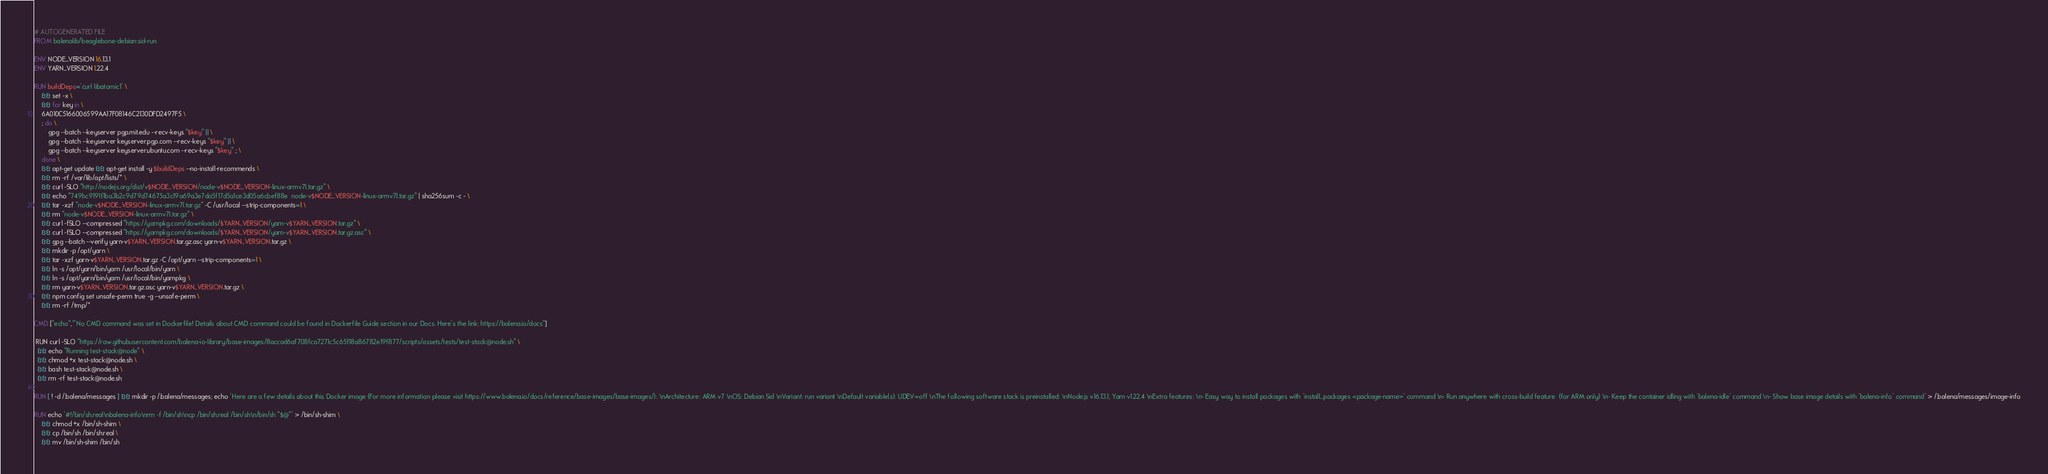Convert code to text. <code><loc_0><loc_0><loc_500><loc_500><_Dockerfile_># AUTOGENERATED FILE
FROM balenalib/beaglebone-debian:sid-run

ENV NODE_VERSION 16.13.1
ENV YARN_VERSION 1.22.4

RUN buildDeps='curl libatomic1' \
	&& set -x \
	&& for key in \
	6A010C5166006599AA17F08146C2130DFD2497F5 \
	; do \
		gpg --batch --keyserver pgp.mit.edu --recv-keys "$key" || \
		gpg --batch --keyserver keyserver.pgp.com --recv-keys "$key" || \
		gpg --batch --keyserver keyserver.ubuntu.com --recv-keys "$key" ; \
	done \
	&& apt-get update && apt-get install -y $buildDeps --no-install-recommends \
	&& rm -rf /var/lib/apt/lists/* \
	&& curl -SLO "http://nodejs.org/dist/v$NODE_VERSION/node-v$NODE_VERSION-linux-armv7l.tar.gz" \
	&& echo "749bc9191f1ba3b2c9d79d74675a3c19a69a3e7da5f17d5a1ce3d05a6cbef88e  node-v$NODE_VERSION-linux-armv7l.tar.gz" | sha256sum -c - \
	&& tar -xzf "node-v$NODE_VERSION-linux-armv7l.tar.gz" -C /usr/local --strip-components=1 \
	&& rm "node-v$NODE_VERSION-linux-armv7l.tar.gz" \
	&& curl -fSLO --compressed "https://yarnpkg.com/downloads/$YARN_VERSION/yarn-v$YARN_VERSION.tar.gz" \
	&& curl -fSLO --compressed "https://yarnpkg.com/downloads/$YARN_VERSION/yarn-v$YARN_VERSION.tar.gz.asc" \
	&& gpg --batch --verify yarn-v$YARN_VERSION.tar.gz.asc yarn-v$YARN_VERSION.tar.gz \
	&& mkdir -p /opt/yarn \
	&& tar -xzf yarn-v$YARN_VERSION.tar.gz -C /opt/yarn --strip-components=1 \
	&& ln -s /opt/yarn/bin/yarn /usr/local/bin/yarn \
	&& ln -s /opt/yarn/bin/yarn /usr/local/bin/yarnpkg \
	&& rm yarn-v$YARN_VERSION.tar.gz.asc yarn-v$YARN_VERSION.tar.gz \
	&& npm config set unsafe-perm true -g --unsafe-perm \
	&& rm -rf /tmp/*

CMD ["echo","'No CMD command was set in Dockerfile! Details about CMD command could be found in Dockerfile Guide section in our Docs. Here's the link: https://balena.io/docs"]

 RUN curl -SLO "https://raw.githubusercontent.com/balena-io-library/base-images/8accad6af708fca7271c5c65f18a86782e19f877/scripts/assets/tests/test-stack@node.sh" \
  && echo "Running test-stack@node" \
  && chmod +x test-stack@node.sh \
  && bash test-stack@node.sh \
  && rm -rf test-stack@node.sh 

RUN [ ! -d /.balena/messages ] && mkdir -p /.balena/messages; echo 'Here are a few details about this Docker image (For more information please visit https://www.balena.io/docs/reference/base-images/base-images/): \nArchitecture: ARM v7 \nOS: Debian Sid \nVariant: run variant \nDefault variable(s): UDEV=off \nThe following software stack is preinstalled: \nNode.js v16.13.1, Yarn v1.22.4 \nExtra features: \n- Easy way to install packages with `install_packages <package-name>` command \n- Run anywhere with cross-build feature  (for ARM only) \n- Keep the container idling with `balena-idle` command \n- Show base image details with `balena-info` command' > /.balena/messages/image-info

RUN echo '#!/bin/sh.real\nbalena-info\nrm -f /bin/sh\ncp /bin/sh.real /bin/sh\n/bin/sh "$@"' > /bin/sh-shim \
	&& chmod +x /bin/sh-shim \
	&& cp /bin/sh /bin/sh.real \
	&& mv /bin/sh-shim /bin/sh</code> 